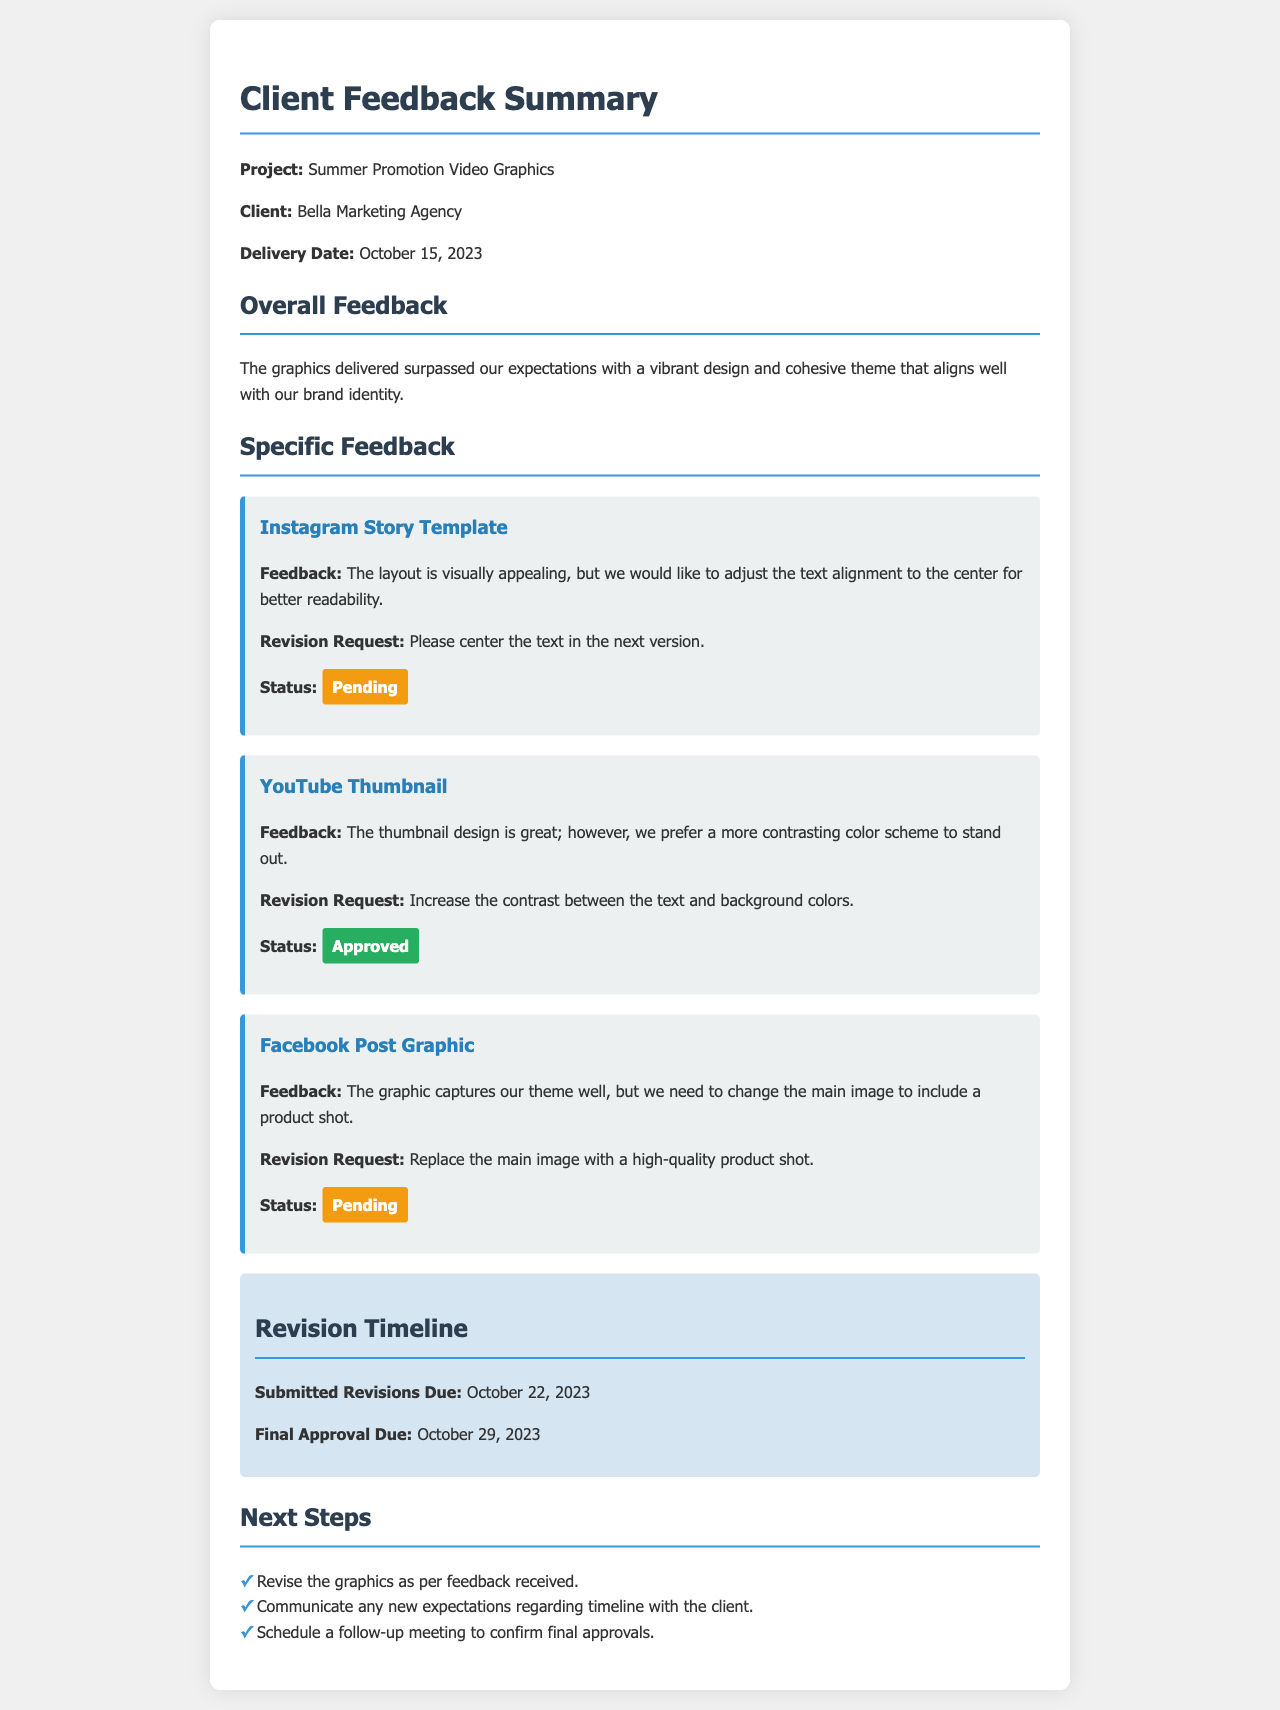What is the project title? The project title is clearly stated at the beginning of the document as "Summer Promotion Video Graphics."
Answer: Summer Promotion Video Graphics Who is the client? The client’s name is provided in the document under the client section, which is "Bella Marketing Agency."
Answer: Bella Marketing Agency When was the delivery date? The delivery date can be found in the document as stated, which is "October 15, 2023."
Answer: October 15, 2023 What is the status of the Instagram Story Template revision? The status of the Instagram Story Template is mentioned as "Pending" in the feedback section.
Answer: Pending What revision is requested for the YouTube Thumbnail? The document explicitly states that the request is to "Increase the contrast between the text and background colors."
Answer: Increase the contrast between the text and background colors When are the submitted revisions due? The due date for the submitted revisions is detailed in the timeline section as "October 22, 2023."
Answer: October 22, 2023 How many total revision requests are pending? The feedback section shows two items with a "Pending" status, indicating the total number of pending requests.
Answer: 2 What is the final approval due date? The final approval due date is provided in the document as "October 29, 2023."
Answer: October 29, 2023 What are the next steps to be taken? The document lists three specific actions to take as next steps regarding revisions and client communication.
Answer: Revise the graphics as per feedback received 